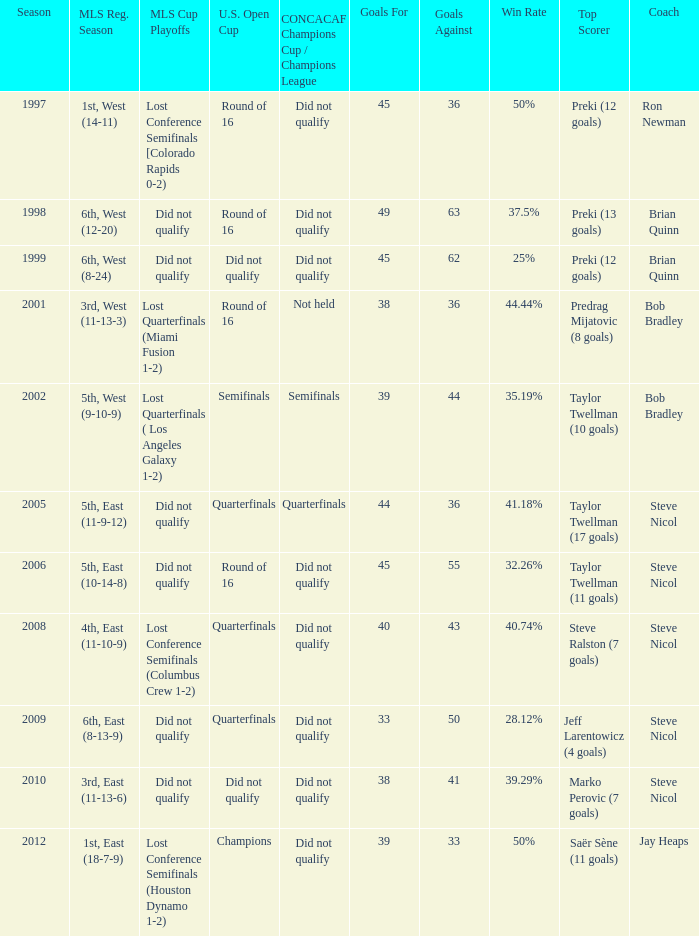What were the placements of the team in regular season when they reached quarterfinals in the U.S. Open Cup but did not qualify for the Concaf Champions Cup? 4th, East (11-10-9), 6th, East (8-13-9). 